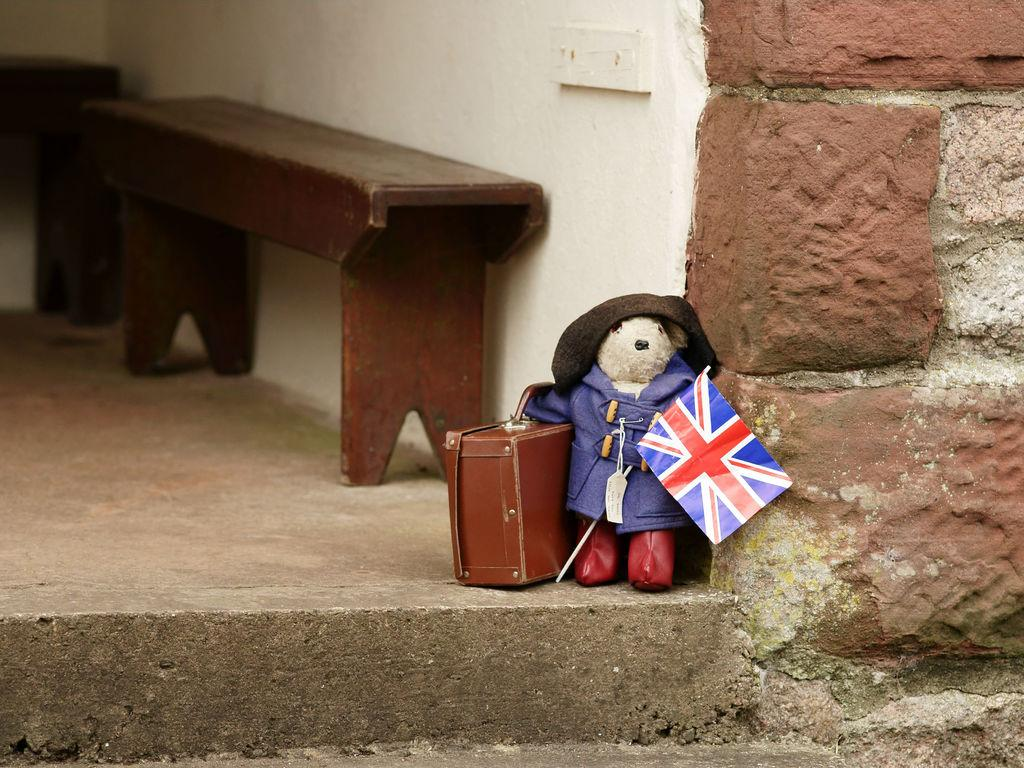What is on the ground in the image? There is a toy on the ground. What is the toy holding in its hand? The toy is holding a flag in its hand. What else is the toy holding? The toy is also holding a suitcase. What can be seen in the background of the image? There is a wall in the background. What type of haircut does the animal in the image have? There is no animal present in the image, so it is not possible to determine the type of haircut it might have. 